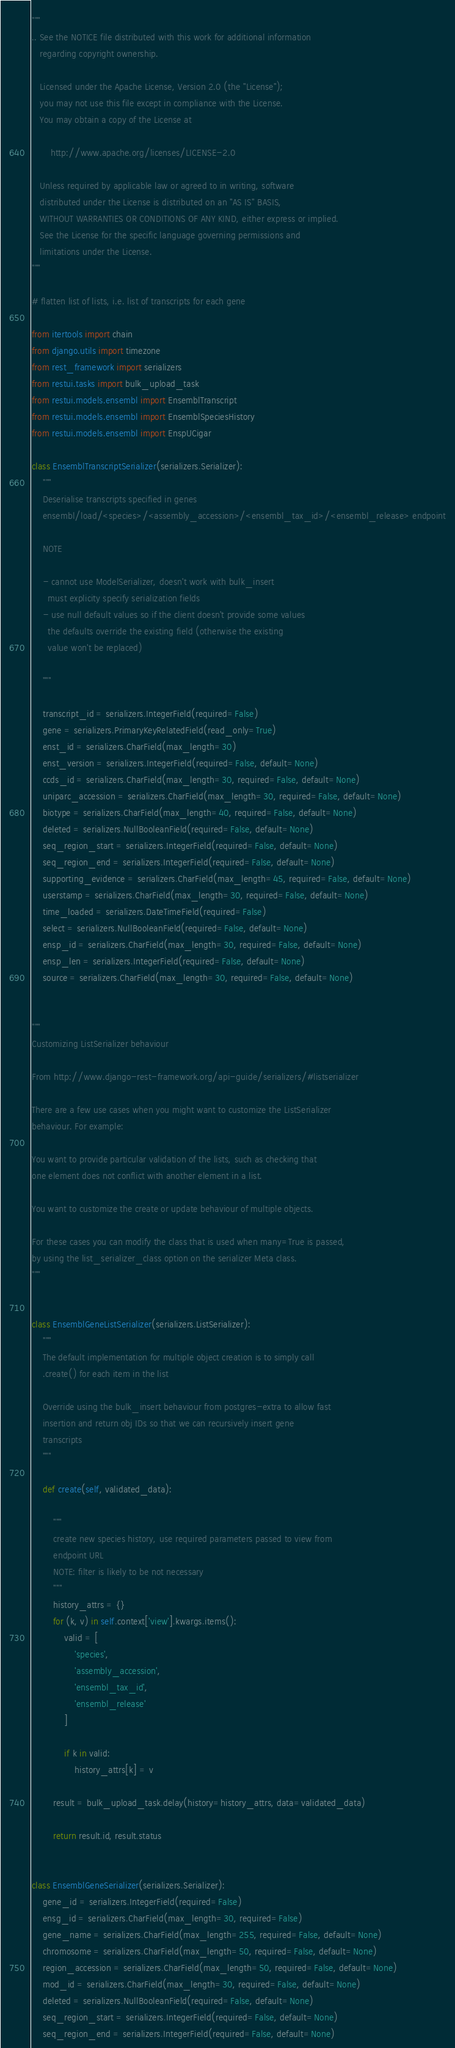<code> <loc_0><loc_0><loc_500><loc_500><_Python_>"""
.. See the NOTICE file distributed with this work for additional information
   regarding copyright ownership.

   Licensed under the Apache License, Version 2.0 (the "License");
   you may not use this file except in compliance with the License.
   You may obtain a copy of the License at

       http://www.apache.org/licenses/LICENSE-2.0

   Unless required by applicable law or agreed to in writing, software
   distributed under the License is distributed on an "AS IS" BASIS,
   WITHOUT WARRANTIES OR CONDITIONS OF ANY KIND, either express or implied.
   See the License for the specific language governing permissions and
   limitations under the License.
"""

# flatten list of lists, i.e. list of transcripts for each gene

from itertools import chain
from django.utils import timezone
from rest_framework import serializers
from restui.tasks import bulk_upload_task
from restui.models.ensembl import EnsemblTranscript
from restui.models.ensembl import EnsemblSpeciesHistory
from restui.models.ensembl import EnspUCigar

class EnsemblTranscriptSerializer(serializers.Serializer):
    """
    Deserialise transcripts specified in genes
    ensembl/load/<species>/<assembly_accession>/<ensembl_tax_id>/<ensembl_release> endpoint

    NOTE

    - cannot use ModelSerializer, doesn't work with bulk_insert
      must explicity specify serialization fields
    - use null default values so if the client doesn't provide some values
      the defaults override the existing field (otherwise the existing
      value won't be replaced)

    """

    transcript_id = serializers.IntegerField(required=False)
    gene = serializers.PrimaryKeyRelatedField(read_only=True)
    enst_id = serializers.CharField(max_length=30)
    enst_version = serializers.IntegerField(required=False, default=None)
    ccds_id = serializers.CharField(max_length=30, required=False, default=None)
    uniparc_accession = serializers.CharField(max_length=30, required=False, default=None)
    biotype = serializers.CharField(max_length=40, required=False, default=None)
    deleted = serializers.NullBooleanField(required=False, default=None)
    seq_region_start = serializers.IntegerField(required=False, default=None)
    seq_region_end = serializers.IntegerField(required=False, default=None)
    supporting_evidence = serializers.CharField(max_length=45, required=False, default=None)
    userstamp = serializers.CharField(max_length=30, required=False, default=None)
    time_loaded = serializers.DateTimeField(required=False)
    select = serializers.NullBooleanField(required=False, default=None)
    ensp_id = serializers.CharField(max_length=30, required=False, default=None)
    ensp_len = serializers.IntegerField(required=False, default=None)
    source = serializers.CharField(max_length=30, required=False, default=None)


"""
Customizing ListSerializer behaviour

From http://www.django-rest-framework.org/api-guide/serializers/#listserializer

There are a few use cases when you might want to customize the ListSerializer
behaviour. For example:

You want to provide particular validation of the lists, such as checking that
one element does not conflict with another element in a list.

You want to customize the create or update behaviour of multiple objects.

For these cases you can modify the class that is used when many=True is passed,
by using the list_serializer_class option on the serializer Meta class.
"""


class EnsemblGeneListSerializer(serializers.ListSerializer):
    """
    The default implementation for multiple object creation is to simply call
    .create() for each item in the list

    Override using the bulk_insert behaviour from postgres-extra to allow fast
    insertion and return obj IDs so that we can recursively insert gene
    transcripts
    """

    def create(self, validated_data):

        """
        create new species history, use required parameters passed to view from
        endpoint URL
        NOTE: filter is likely to be not necessary
        """
        history_attrs = {}
        for (k, v) in self.context['view'].kwargs.items():
            valid = [
                'species',
                'assembly_accession',
                'ensembl_tax_id',
                'ensembl_release'
            ]

            if k in valid:
                history_attrs[k] = v

        result = bulk_upload_task.delay(history=history_attrs, data=validated_data)

        return result.id, result.status


class EnsemblGeneSerializer(serializers.Serializer):
    gene_id = serializers.IntegerField(required=False)
    ensg_id = serializers.CharField(max_length=30, required=False)
    gene_name = serializers.CharField(max_length=255, required=False, default=None)
    chromosome = serializers.CharField(max_length=50, required=False, default=None)
    region_accession = serializers.CharField(max_length=50, required=False, default=None)
    mod_id = serializers.CharField(max_length=30, required=False, default=None)
    deleted = serializers.NullBooleanField(required=False, default=None)
    seq_region_start = serializers.IntegerField(required=False, default=None)
    seq_region_end = serializers.IntegerField(required=False, default=None)</code> 